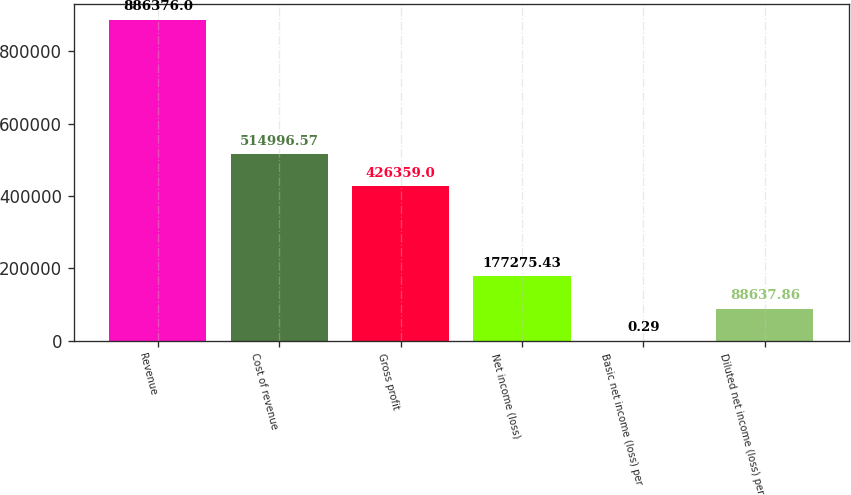Convert chart to OTSL. <chart><loc_0><loc_0><loc_500><loc_500><bar_chart><fcel>Revenue<fcel>Cost of revenue<fcel>Gross profit<fcel>Net income (loss)<fcel>Basic net income (loss) per<fcel>Diluted net income (loss) per<nl><fcel>886376<fcel>514997<fcel>426359<fcel>177275<fcel>0.29<fcel>88637.9<nl></chart> 